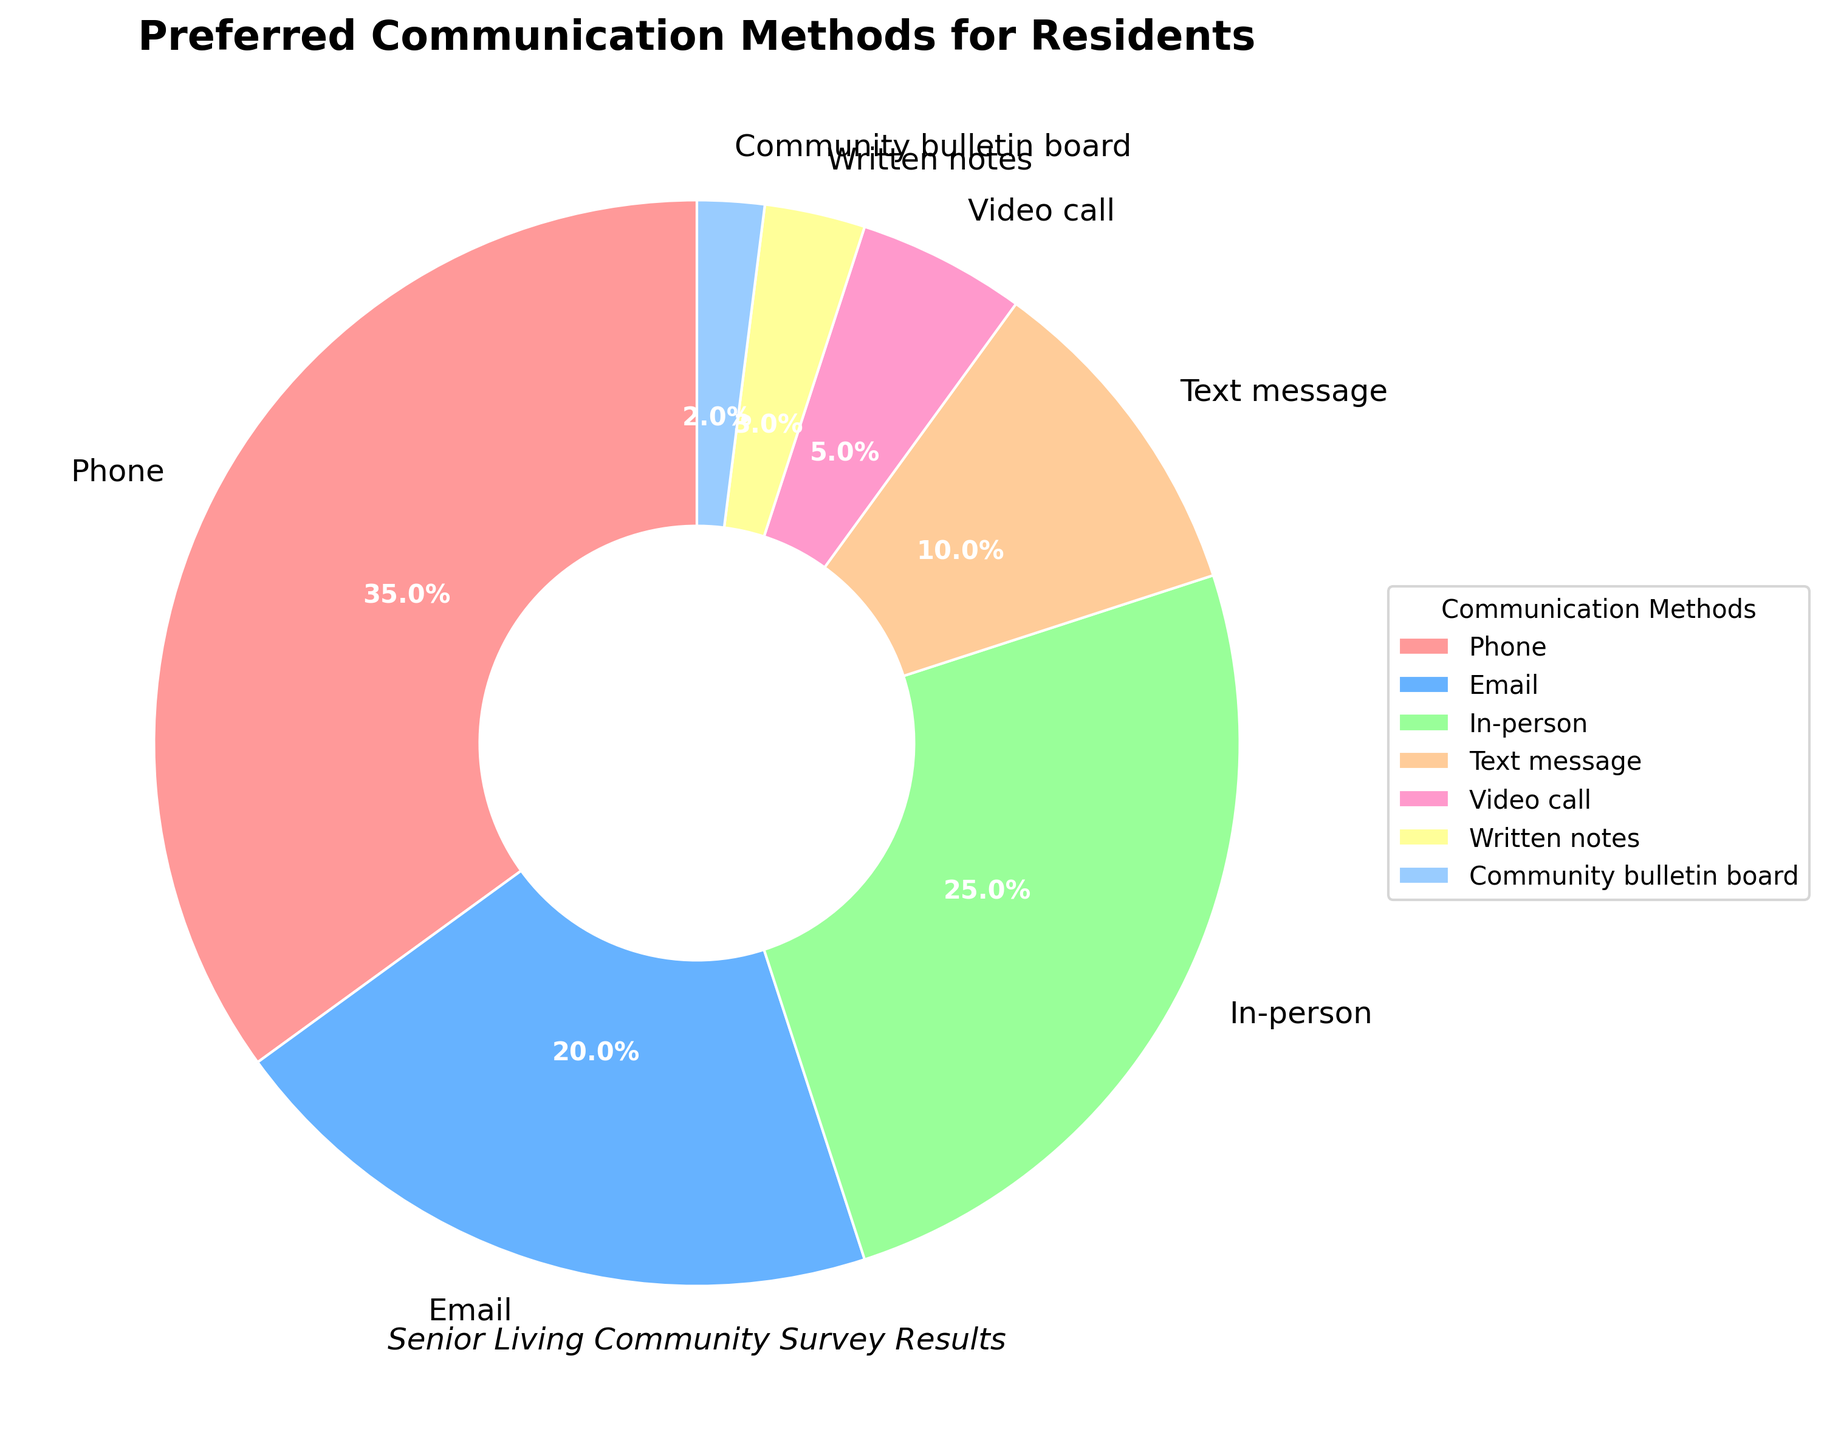What is the most preferred communication method among residents? The largest segment of the pie chart represents the communication method with the highest percentage. The label shows that Phone has the largest segment.
Answer: Phone What percentage prefer email as their communication method? Locate the segment labeled 'Email' in the pie chart and read the percentage indicated on it, which is 20%.
Answer: 20% Which communication method is preferred by fewer residents, written notes or video call? Compare the segments labeled 'Written notes' and 'Video call' in the pie chart. The percentage for Written notes is 3% and for Video call is 5%. Written notes have a smaller percentage.
Answer: Written notes What is the combined percentage of residents who prefer text message and community bulletin board communication methods? Add the percentages for 'Text message' (10%) and 'Community bulletin board' (2%) from the pie chart. 10% + 2% = 12%.
Answer: 12% Are there more residents who prefer in-person communication or those who prefer email and video call combined? In-person communication has a percentage of 25%. The combined percentage of Email (20%) and Video call (5%) is 25%. Since 25% (in-person) is equal to 25% (email + video call), they are the same.
Answer: They are the same Which communication method has almost half the preference of the most preferred method? The most preferred method is Phone with 35%. Half of 35% is 17.5%. Closest to this value is Email with 20%.
Answer: Email Between text message and in-person communication, which method has the higher preference and by how much? In-person has 25% preference whereas Text message has 10%. The difference is 25% - 10% = 15%.
Answer: In-person, by 15% What is the total percentage of residents who prefer either phone or email? Sum the percentages of residents preferring Phone (35%) and Email (20%). 35% + 20% = 55%.
Answer: 55% Which color represents the least preferred communication method, and what is this method? The smallest segment represents 'Community bulletin board' with 2%. The corresponding color for this segment (from the list) is light blue.
Answer: Light blue, Community bulletin board 